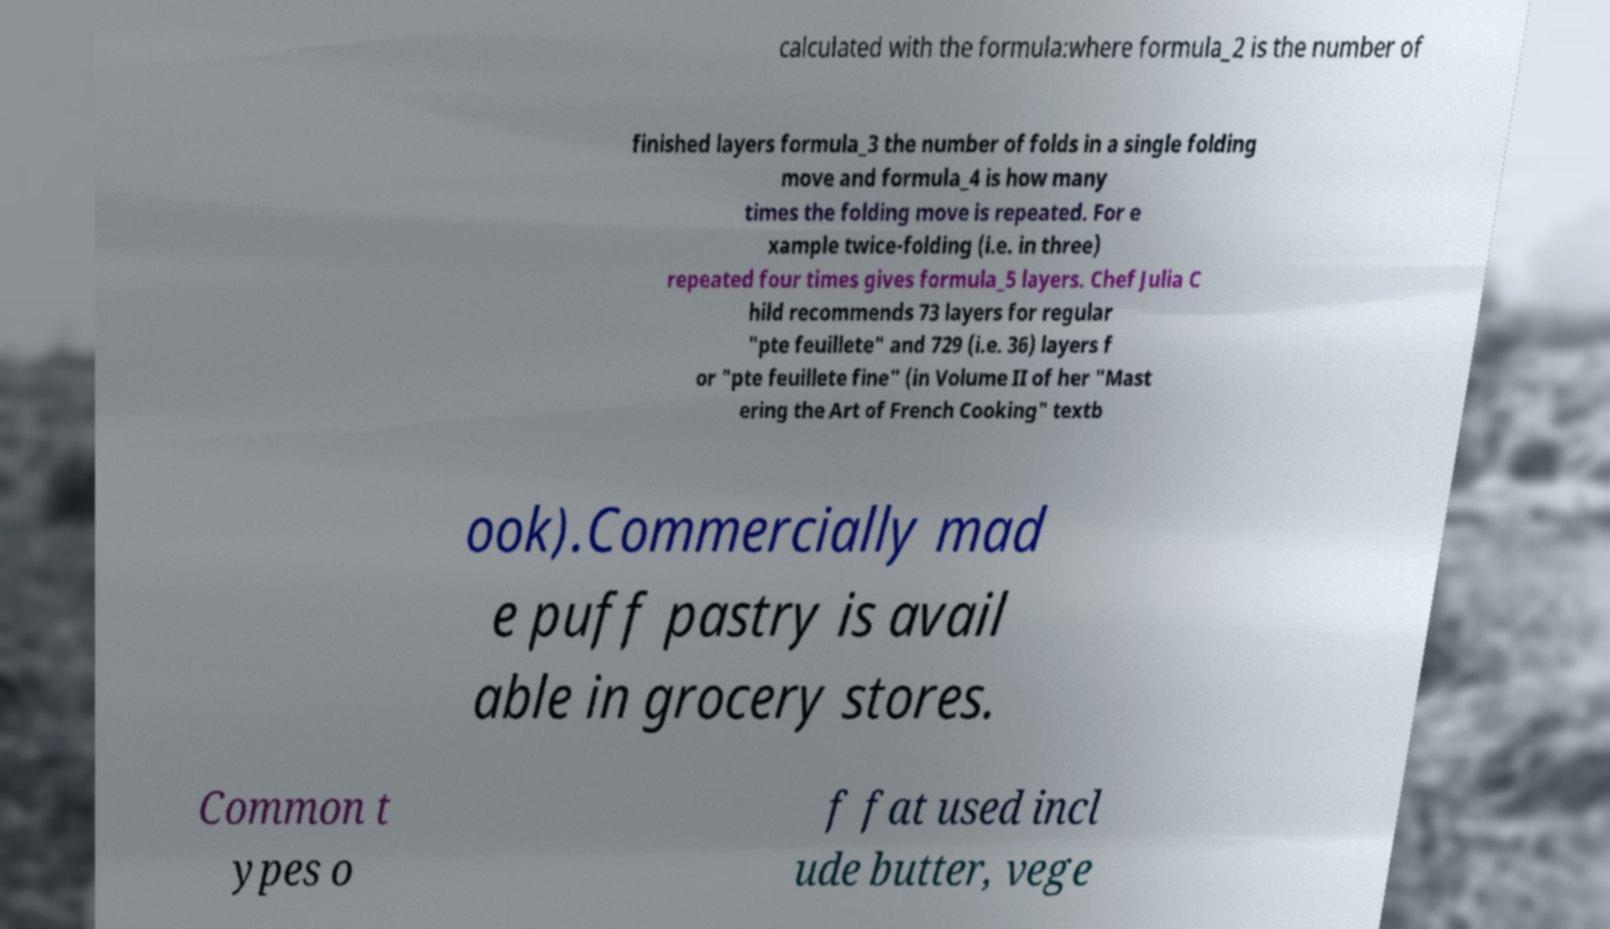What messages or text are displayed in this image? I need them in a readable, typed format. calculated with the formula:where formula_2 is the number of finished layers formula_3 the number of folds in a single folding move and formula_4 is how many times the folding move is repeated. For e xample twice-folding (i.e. in three) repeated four times gives formula_5 layers. Chef Julia C hild recommends 73 layers for regular "pte feuillete" and 729 (i.e. 36) layers f or "pte feuillete fine" (in Volume II of her "Mast ering the Art of French Cooking" textb ook).Commercially mad e puff pastry is avail able in grocery stores. Common t ypes o f fat used incl ude butter, vege 